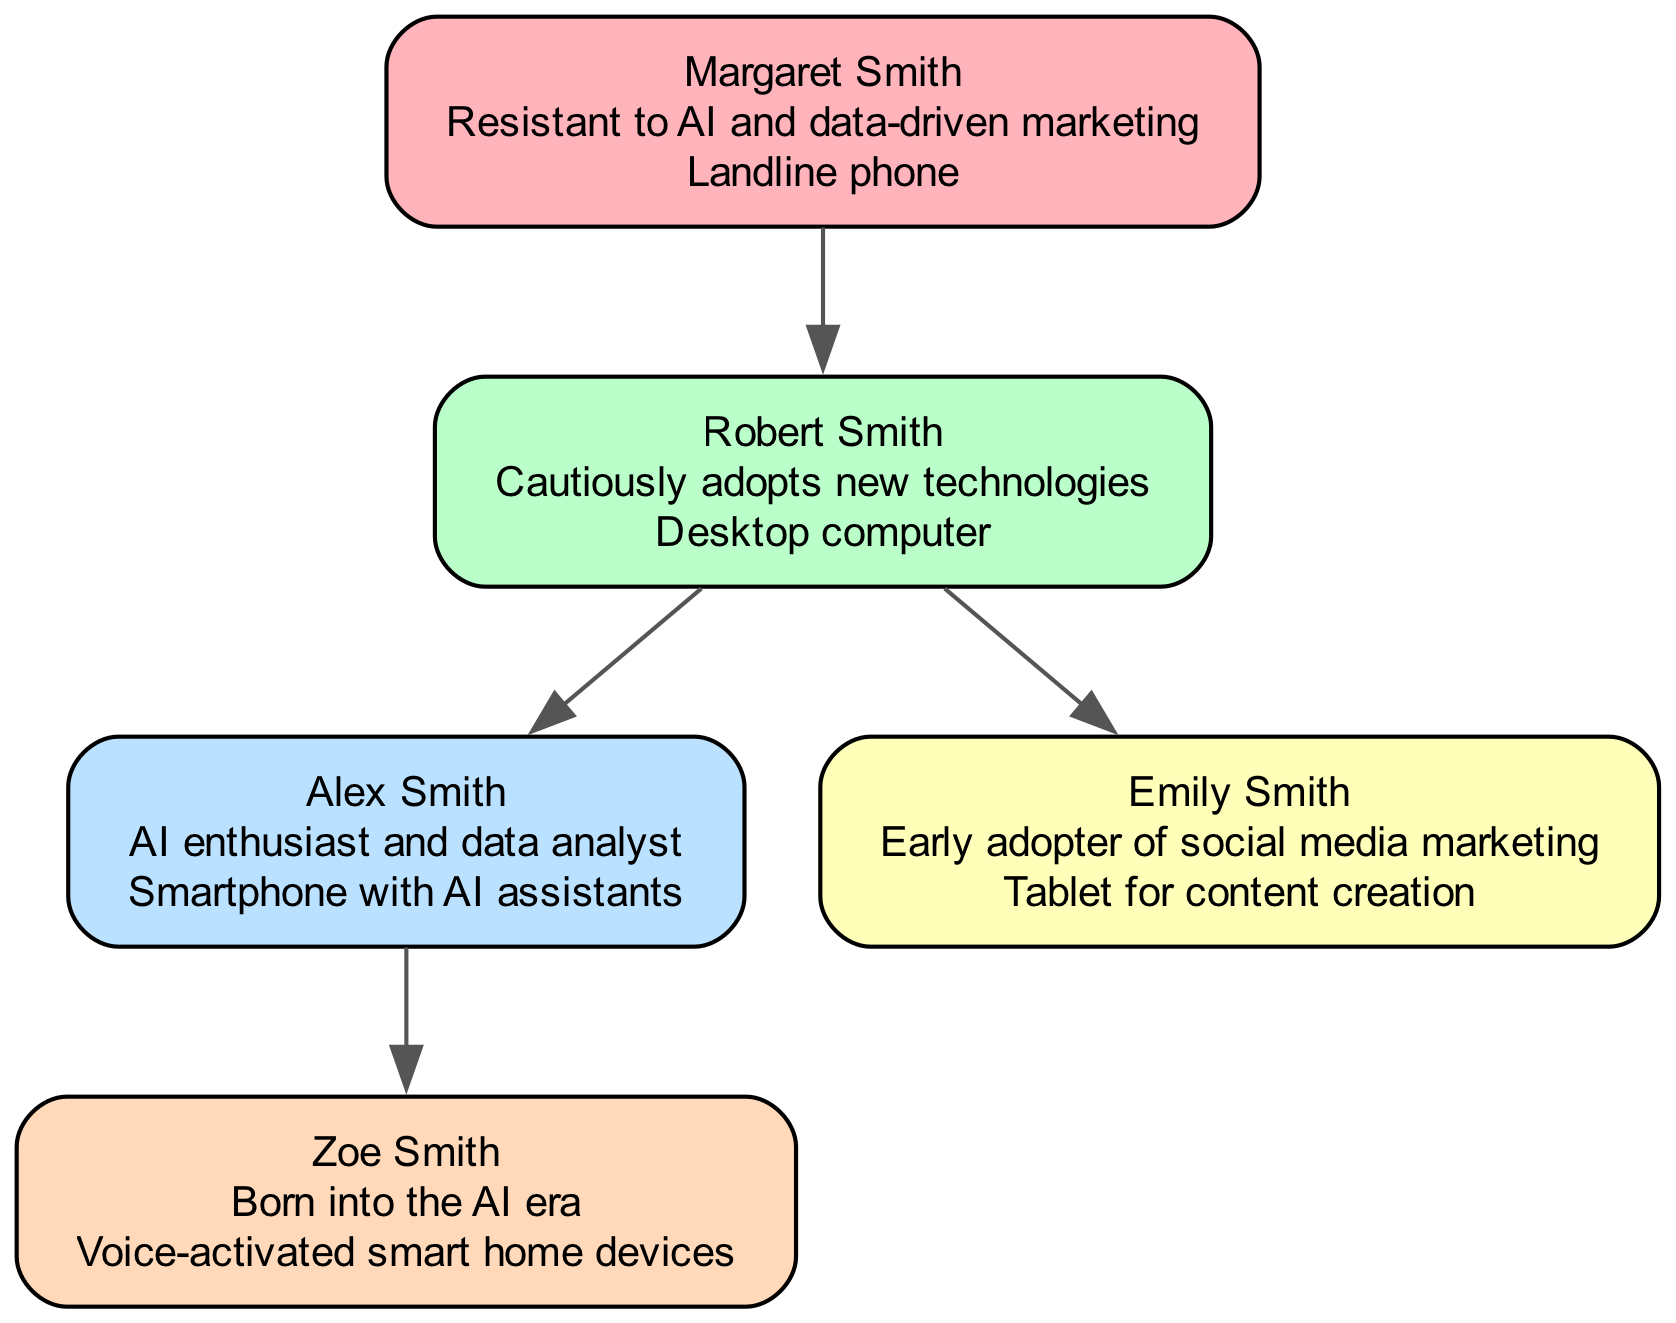What is the name of the grandparent in the family tree? The diagram lists the grandparent's name as Margaret Smith.
Answer: Margaret Smith Which device does Emily Smith prefer? According to the diagram, Emily Smith's favorite device is a Tablet for content creation.
Answer: Tablet for content creation How many nodes are there in total in the family tree? The diagram includes five distinct family members, which are the grandparent, parent, self, sibling, and child, making a total of five nodes.
Answer: 5 What is Robert Smith's attitude towards technology? The diagram indicates that Robert Smith has a cautious attitude toward adopting new technologies.
Answer: Cautiously adopts new technologies Who is the child of Alex Smith? Looking at the relationships depicted in the diagram, Zoe Smith is shown as the child of Alex Smith.
Answer: Zoe Smith Which family member is resistant to AI? The diagram specifies that Margaret Smith is resistant to AI and data-driven marketing.
Answer: Margaret Smith Which device is favored by Zoe Smith? Based on the information in the diagram, Zoe Smith's favorite device is a voice-activated smart home device.
Answer: Voice-activated smart home devices From which generation does the early adopter of social media marketing come? The diagram shows that Emily Smith, who is an early adopter of social media marketing, belongs to the sibling generation.
Answer: Sibling What color represents the parent in the family tree diagram? The diagram uses light green to denote the parent, Robert Smith.
Answer: Light green 